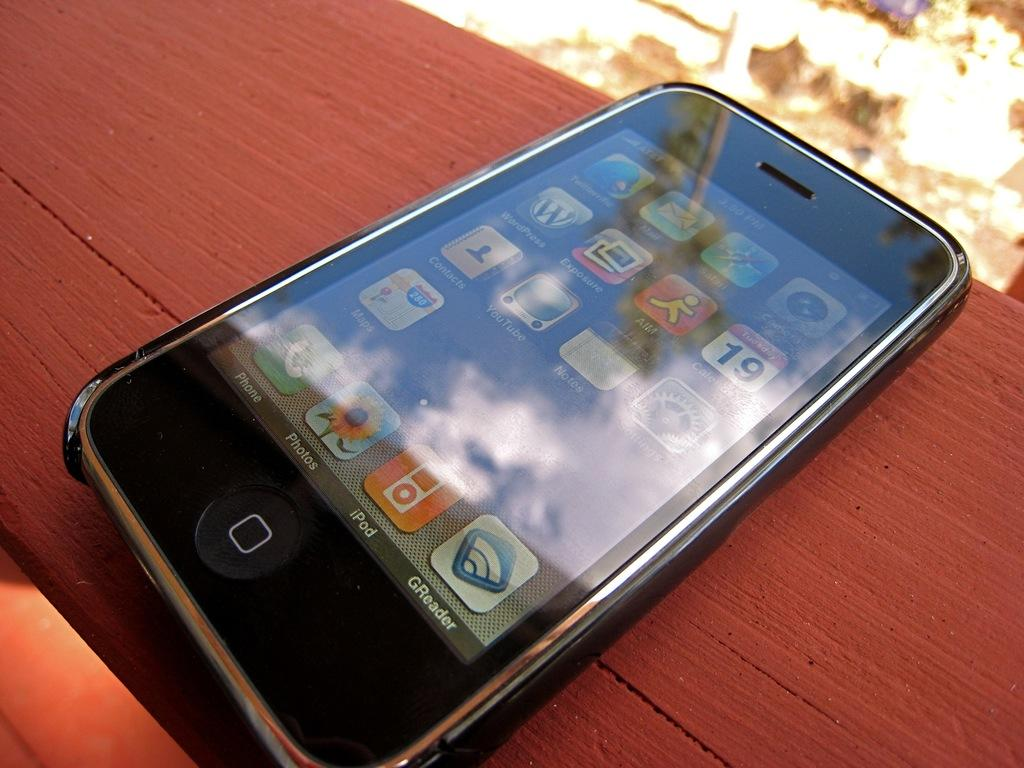<image>
Summarize the visual content of the image. An iPhone shows several apps, one of which is GReader. 